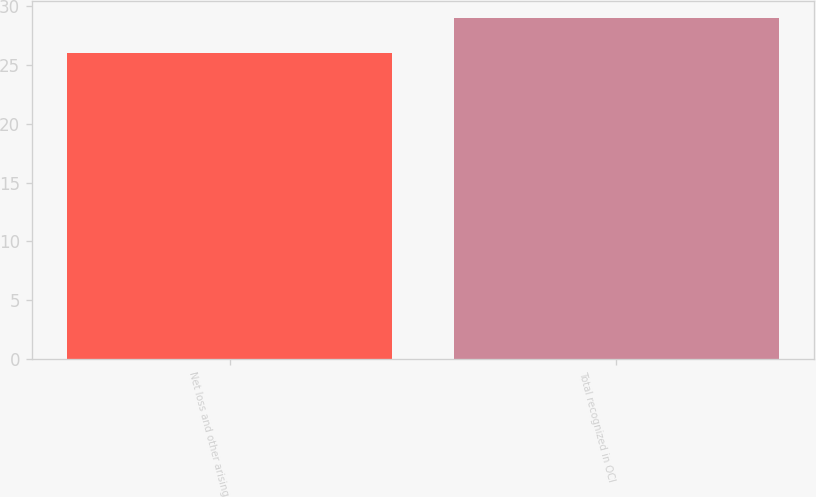<chart> <loc_0><loc_0><loc_500><loc_500><bar_chart><fcel>Net loss and other arising<fcel>Total recognized in OCI<nl><fcel>26<fcel>29<nl></chart> 